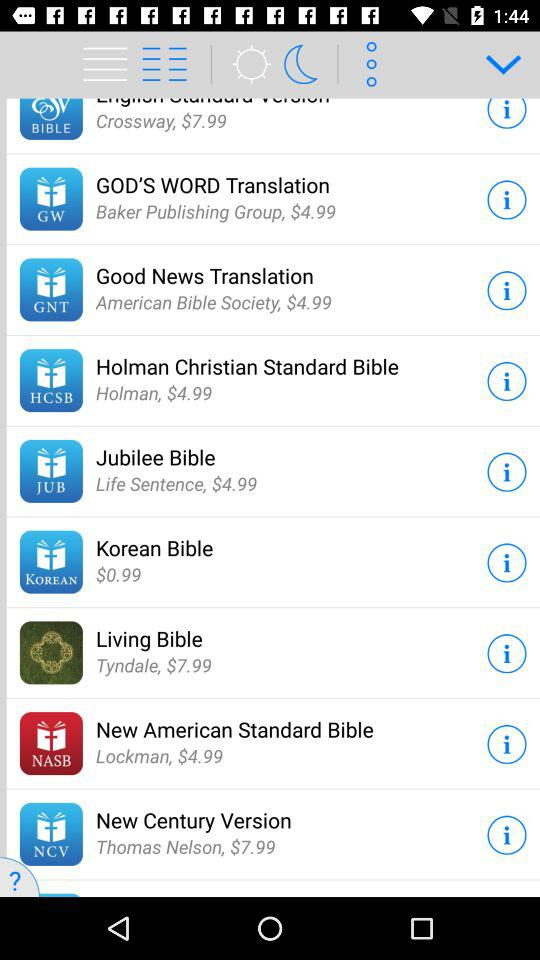How many Bible translations are available for purchase?
Answer the question using a single word or phrase. 9 